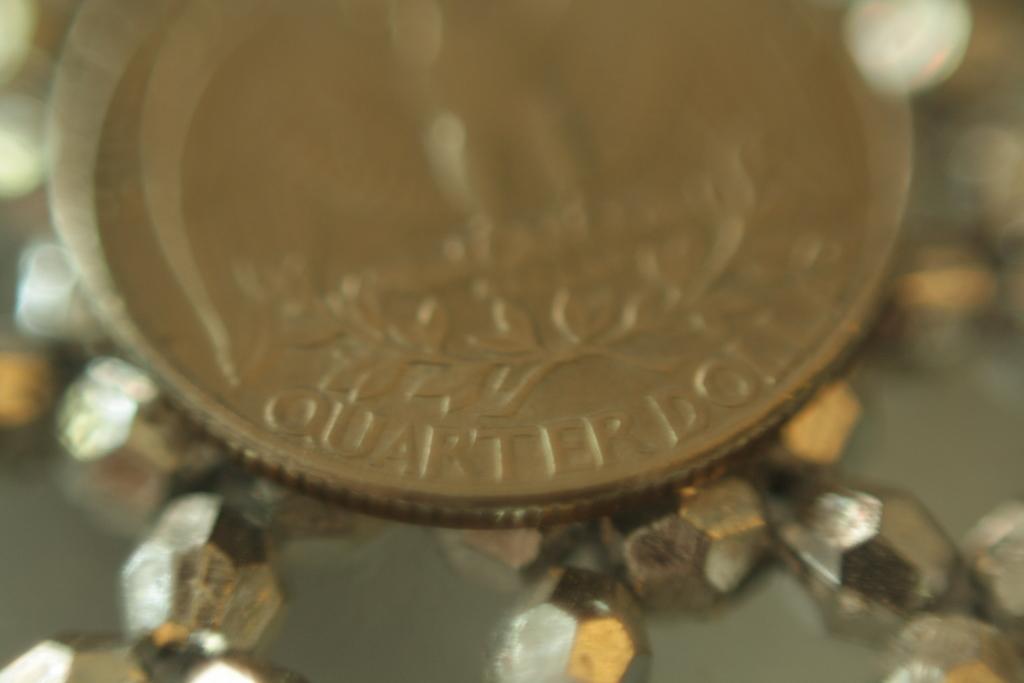How would you summarize this image in a sentence or two? This picture contains a dollar or a coin. On the coin, it is written as "Quarter Dollar". At the bottom of the picture, we see beads. It is blurred in the background. 